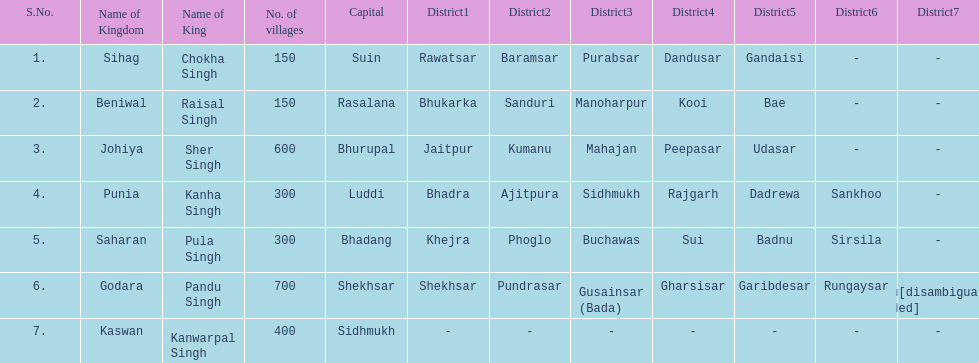Which kingdom contained the second most villages, next only to godara? Johiya. 